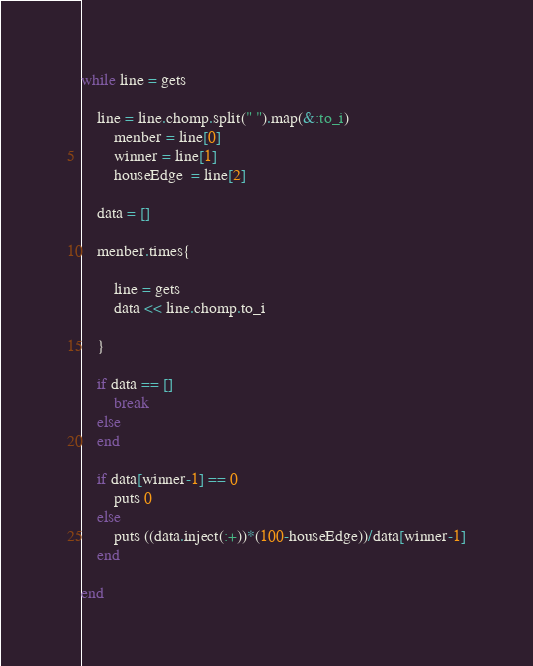Convert code to text. <code><loc_0><loc_0><loc_500><loc_500><_Ruby_>while line = gets

    line = line.chomp.split(" ").map(&:to_i)
        menber = line[0]
        winner = line[1]
        houseEdge  = line[2]
    
    data = []
    
    menber.times{
        
        line = gets
        data << line.chomp.to_i
        
    }
    
    if data == []
        break
    else 
    end 
    
    if data[winner-1] == 0 
        puts 0 
    else 
        puts ((data.inject(:+))*(100-houseEdge))/data[winner-1]
    end 
    
end</code> 